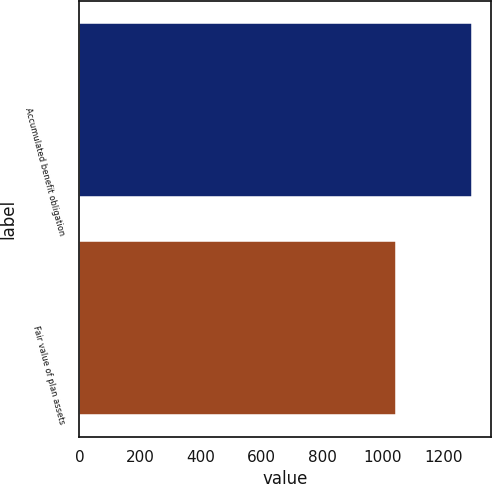Convert chart. <chart><loc_0><loc_0><loc_500><loc_500><bar_chart><fcel>Accumulated benefit obligation<fcel>Fair value of plan assets<nl><fcel>1294<fcel>1044<nl></chart> 